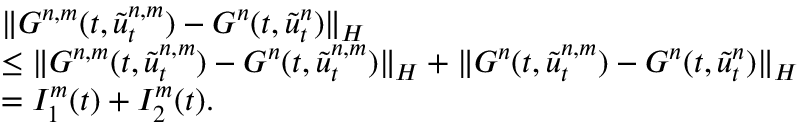Convert formula to latex. <formula><loc_0><loc_0><loc_500><loc_500>\begin{array} { r l } & { \| G ^ { n , m } ( t , \tilde { u } _ { t } ^ { n , m } ) - G ^ { n } ( t , \tilde { u } _ { t } ^ { n } ) \| _ { H } } \\ & { \leq \| G ^ { n , m } ( t , \tilde { u } _ { t } ^ { n , m } ) - G ^ { n } ( t , \tilde { u } _ { t } ^ { n , m } ) \| _ { H } + \| G ^ { n } ( t , \tilde { u } _ { t } ^ { n , m } ) - G ^ { n } ( t , \tilde { u } _ { t } ^ { n } ) \| _ { H } } \\ & { = I _ { 1 } ^ { m } ( t ) + I _ { 2 } ^ { m } ( t ) . } \end{array}</formula> 